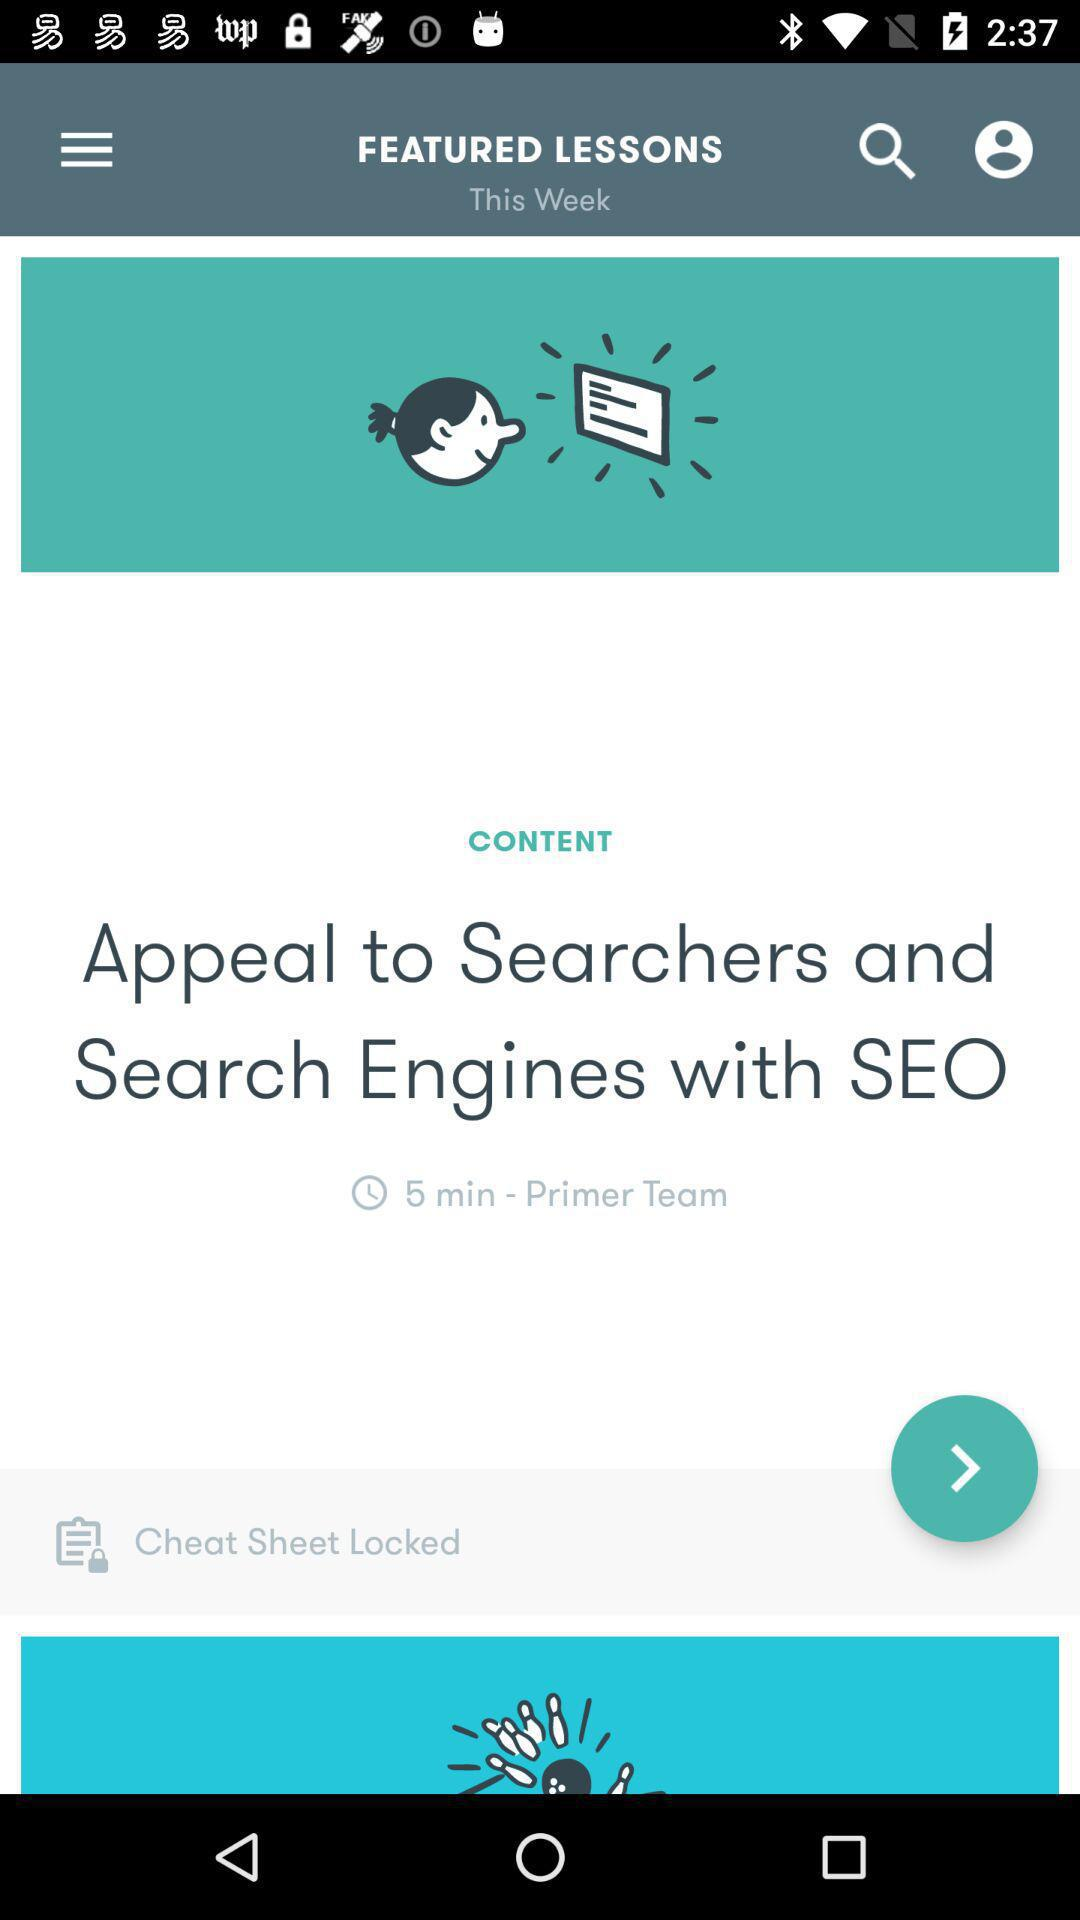Who is the author of the content?
When the provided information is insufficient, respond with <no answer>. <no answer> 